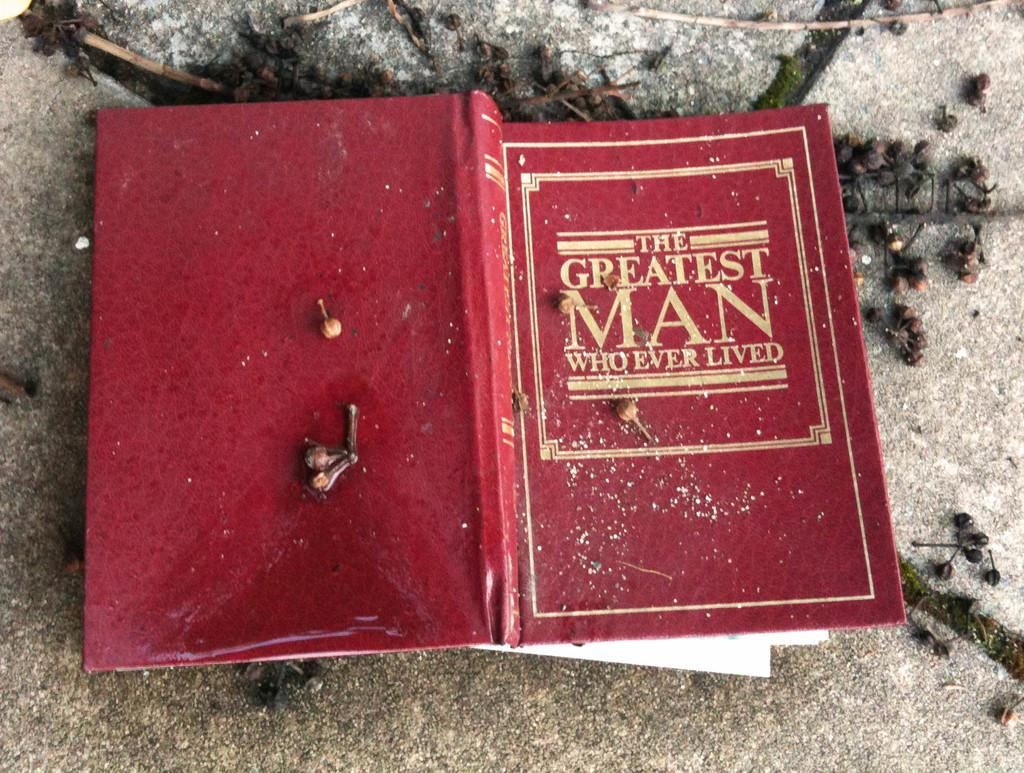<image>
Create a compact narrative representing the image presented. An open book lying flat on a table with a red cover titled The Greatest Man Whoever Lived. 